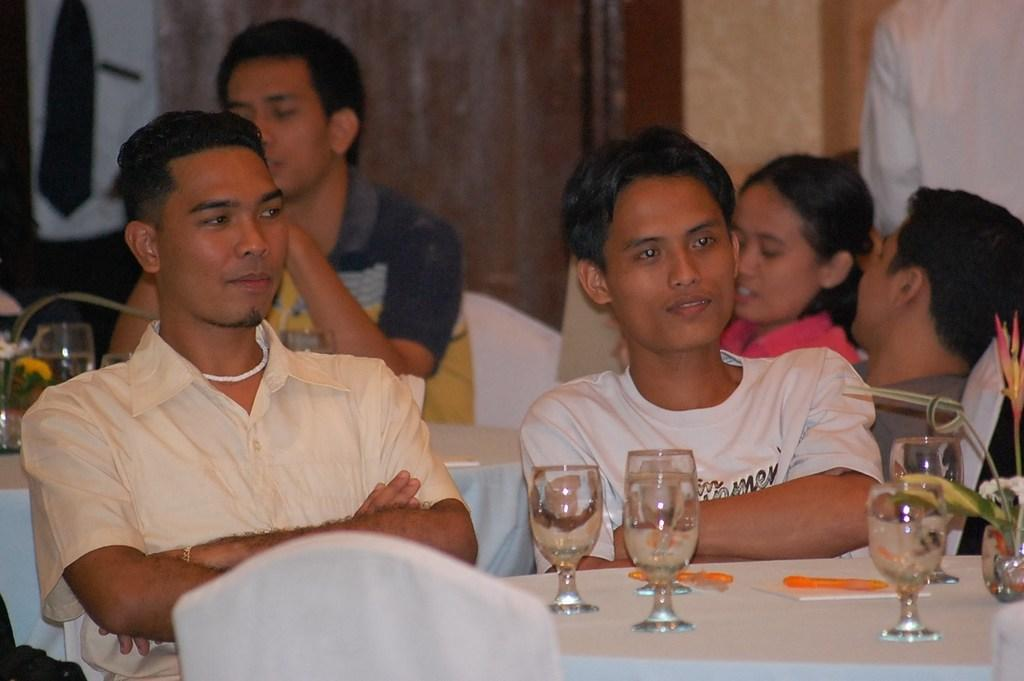What is happening in front of the table in the image? There are persons visible in front of the table. What can be seen inside the glasses on the table? The glasses contain water on the table. Can you describe the contents of the glass on the right side? A leaf is visible in the glass on the right side. What type of work is the pet doing in the image? There is no pet present in the image, so it is not possible to answer that question. What type of produce can be seen in the glass on the left side? There is no produce visible in the image; only a glass of water with a leaf is present. 